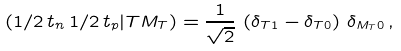<formula> <loc_0><loc_0><loc_500><loc_500>( 1 / 2 \, t _ { n } \, 1 / 2 \, t _ { p } | T M _ { T } ) = \frac { 1 } { \sqrt { 2 } } \, \left ( \delta _ { T 1 } - \delta _ { T 0 } \right ) \, \delta _ { M _ { T } 0 } \, ,</formula> 